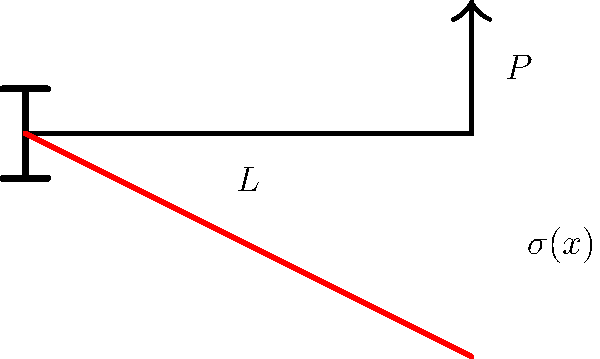For a cantilever beam of length $L$ with a point load $P$ at the free end, the stress distribution $\sigma(x)$ along the beam's length is given by:

$$\sigma(x) = \frac{P(L-x)y}{I}$$

Where $y$ is the distance from the neutral axis and $I$ is the moment of inertia of the beam's cross-section. If $P = 1000 \text{ N}$, $L = 2 \text{ m}$, $y = 0.05 \text{ m}$, and $I = 8 \times 10^{-6} \text{ m}^4$, what is the maximum stress in the beam? To find the maximum stress in the beam, we need to follow these steps:

1. Identify where the maximum stress occurs:
   The maximum stress will be at the fixed end of the beam, where $x = 0$.

2. Substitute the given values into the stress equation:
   $$\sigma(x) = \frac{P(L-x)y}{I}$$
   $$\sigma(0) = \frac{1000 \text{ N} (2 \text{ m} - 0) \cdot 0.05 \text{ m}}{8 \times 10^{-6} \text{ m}^4}$$

3. Simplify the equation:
   $$\sigma(0) = \frac{1000 \cdot 2 \cdot 0.05}{8 \times 10^{-6}}$$

4. Calculate the result:
   $$\sigma(0) = \frac{100}{8 \times 10^{-6}} = 12.5 \times 10^6 \text{ Pa} = 12.5 \text{ MPa}$$

Therefore, the maximum stress in the beam is 12.5 MPa.
Answer: 12.5 MPa 